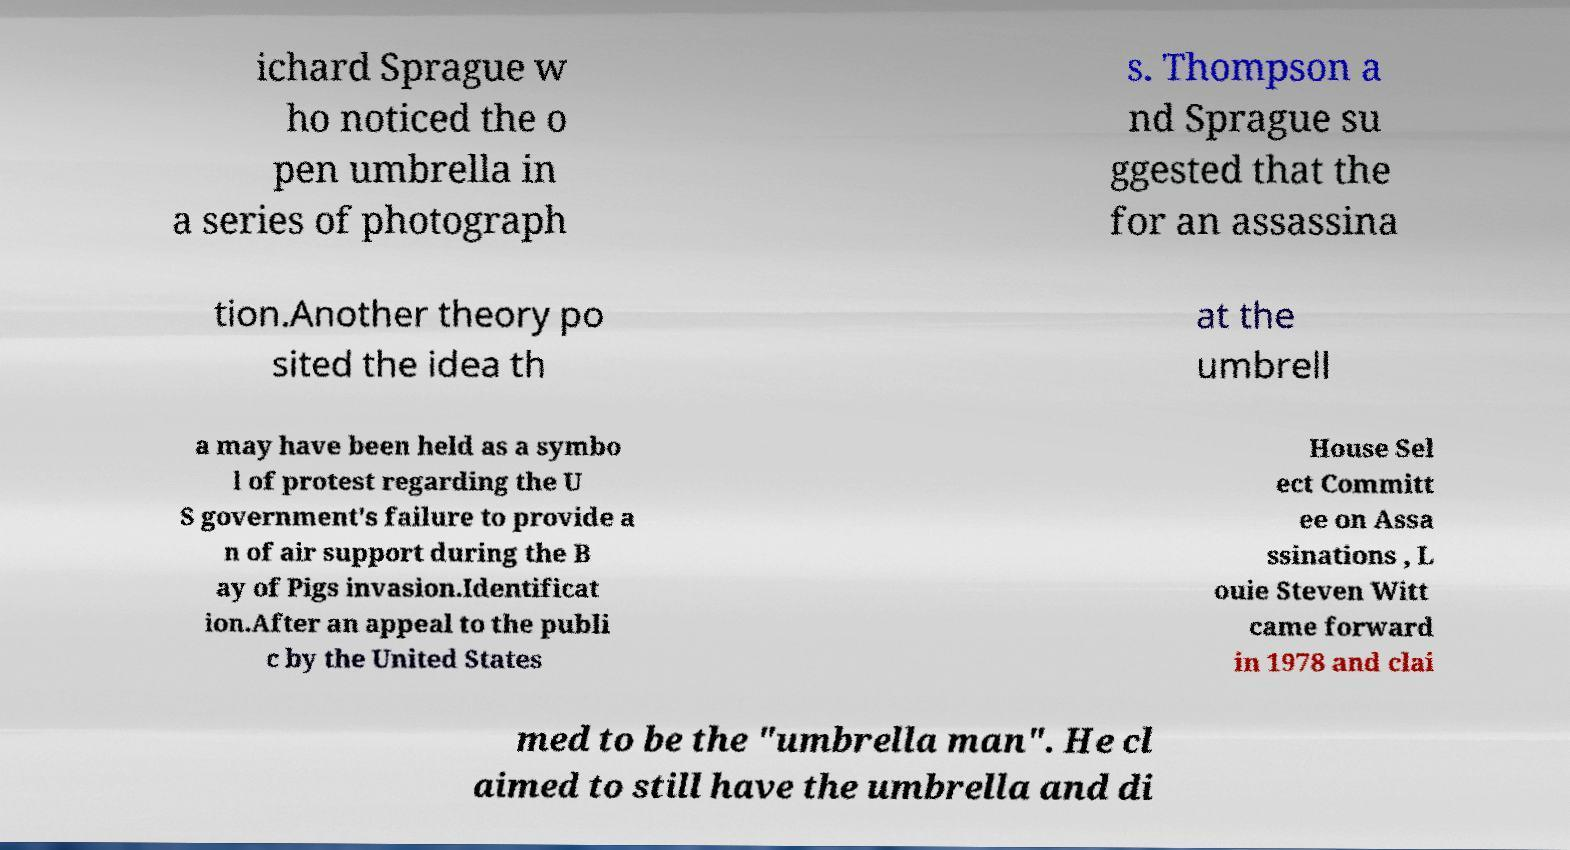Can you read and provide the text displayed in the image?This photo seems to have some interesting text. Can you extract and type it out for me? ichard Sprague w ho noticed the o pen umbrella in a series of photograph s. Thompson a nd Sprague su ggested that the for an assassina tion.Another theory po sited the idea th at the umbrell a may have been held as a symbo l of protest regarding the U S government's failure to provide a n of air support during the B ay of Pigs invasion.Identificat ion.After an appeal to the publi c by the United States House Sel ect Committ ee on Assa ssinations , L ouie Steven Witt came forward in 1978 and clai med to be the "umbrella man". He cl aimed to still have the umbrella and di 